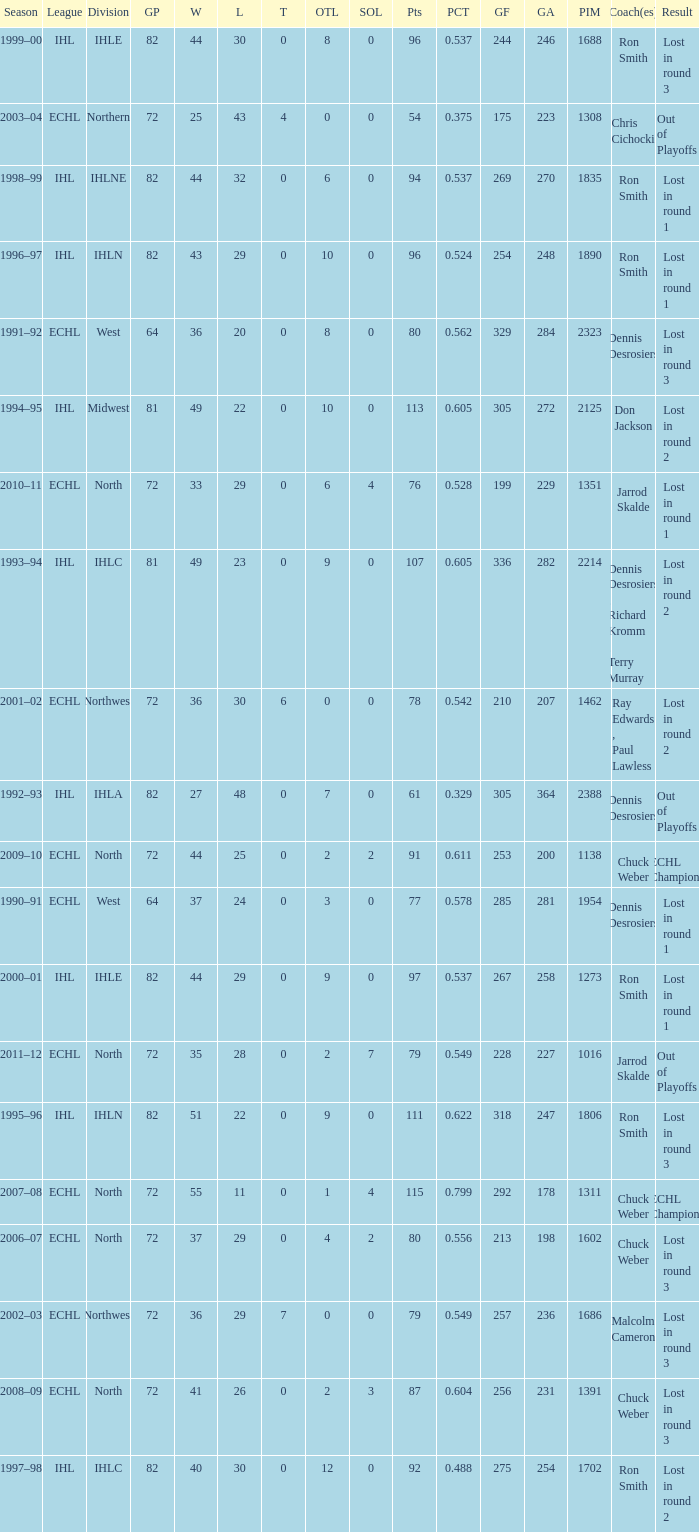What was the maximum OTL if L is 28? 2.0. 